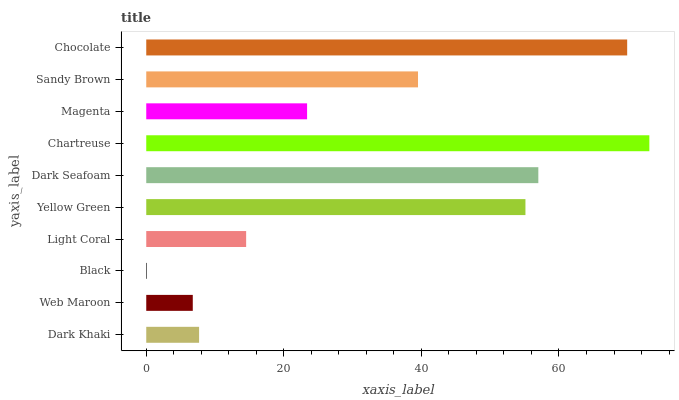Is Black the minimum?
Answer yes or no. Yes. Is Chartreuse the maximum?
Answer yes or no. Yes. Is Web Maroon the minimum?
Answer yes or no. No. Is Web Maroon the maximum?
Answer yes or no. No. Is Dark Khaki greater than Web Maroon?
Answer yes or no. Yes. Is Web Maroon less than Dark Khaki?
Answer yes or no. Yes. Is Web Maroon greater than Dark Khaki?
Answer yes or no. No. Is Dark Khaki less than Web Maroon?
Answer yes or no. No. Is Sandy Brown the high median?
Answer yes or no. Yes. Is Magenta the low median?
Answer yes or no. Yes. Is Black the high median?
Answer yes or no. No. Is Light Coral the low median?
Answer yes or no. No. 